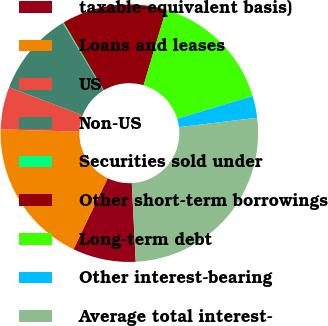Convert chart. <chart><loc_0><loc_0><loc_500><loc_500><pie_chart><fcel>taxable-equivalent basis)<fcel>Loans and leases<fcel>US<fcel>Non-US<fcel>Securities sold under<fcel>Other short-term borrowings<fcel>Long-term debt<fcel>Other interest-bearing<fcel>Average total interest-<nl><fcel>7.93%<fcel>18.33%<fcel>5.34%<fcel>10.53%<fcel>0.14%<fcel>13.13%<fcel>15.73%<fcel>2.74%<fcel>26.13%<nl></chart> 